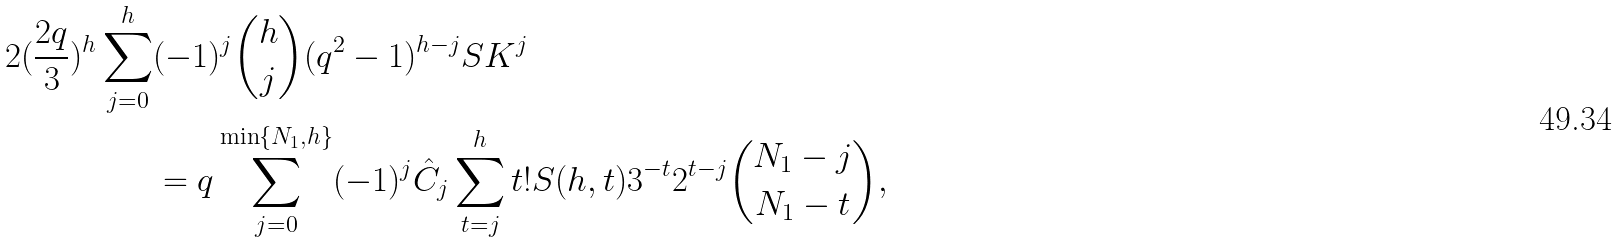Convert formula to latex. <formula><loc_0><loc_0><loc_500><loc_500>2 ( \frac { 2 q } { 3 } ) ^ { h } \sum _ { j = 0 } ^ { h } & ( - 1 ) ^ { j } { \binom { h } { j } } ( q ^ { 2 } - 1 ) ^ { h - j } S K ^ { j } \\ & = q \sum _ { j = 0 } ^ { \min \{ N _ { 1 } , h \} } ( - 1 ) ^ { j } \hat { C } _ { j } \sum _ { t = j } ^ { h } t ! S ( h , t ) 3 ^ { - t } 2 ^ { t - j } { \binom { N _ { 1 } - j } { N _ { 1 } - t } } ,</formula> 